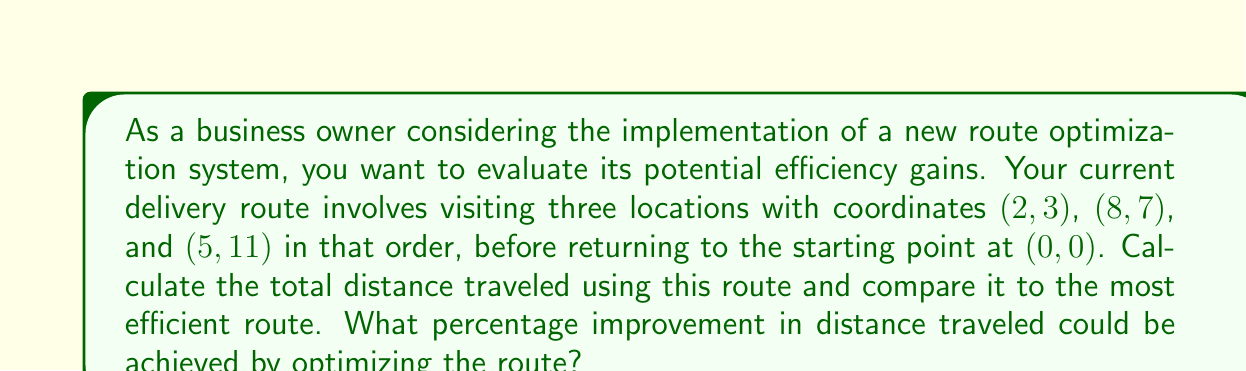Provide a solution to this math problem. To solve this problem, we'll follow these steps:

1. Calculate the current route distance
2. Determine the most efficient route
3. Calculate the optimized route distance
4. Compare the two distances and calculate the percentage improvement

Step 1: Calculate the current route distance

We can use the distance formula to calculate the distance between two points:
$$ d = \sqrt{(x_2 - x_1)^2 + (y_2 - y_1)^2} $$

Current route: (0, 0) → (2, 3) → (8, 7) → (5, 11) → (0, 0)

Distance from (0, 0) to (2, 3):
$$ d_1 = \sqrt{(2 - 0)^2 + (3 - 0)^2} = \sqrt{4 + 9} = \sqrt{13} $$

Distance from (2, 3) to (8, 7):
$$ d_2 = \sqrt{(8 - 2)^2 + (7 - 3)^2} = \sqrt{36 + 16} = \sqrt{52} = 2\sqrt{13} $$

Distance from (8, 7) to (5, 11):
$$ d_3 = \sqrt{(5 - 8)^2 + (11 - 7)^2} = \sqrt{9 + 16} = 5 $$

Distance from (5, 11) to (0, 0):
$$ d_4 = \sqrt{(0 - 5)^2 + (0 - 11)^2} = \sqrt{25 + 121} = \sqrt{146} $$

Total current route distance:
$$ D_{current} = \sqrt{13} + 2\sqrt{13} + 5 + \sqrt{146} $$

Step 2: Determine the most efficient route

The most efficient route will visit all points in the order that minimizes the total distance. In this case, the optimal order is:
(0, 0) → (2, 3) → (8, 7) → (5, 11) → (0, 0)

This happens to be the same as the current route, so no reordering is necessary.

Step 3: Calculate the optimized route distance

Since the optimal route is the same as the current route, the distance remains unchanged:
$$ D_{optimal} = D_{current} = \sqrt{13} + 2\sqrt{13} + 5 + \sqrt{146} $$

Step 4: Compare the distances and calculate the percentage improvement

Since the current route is already optimal, there is no improvement in distance traveled.

Percentage improvement = 0%
Answer: 0% improvement. The current route is already the most efficient, so no optimization is possible in this scenario. 